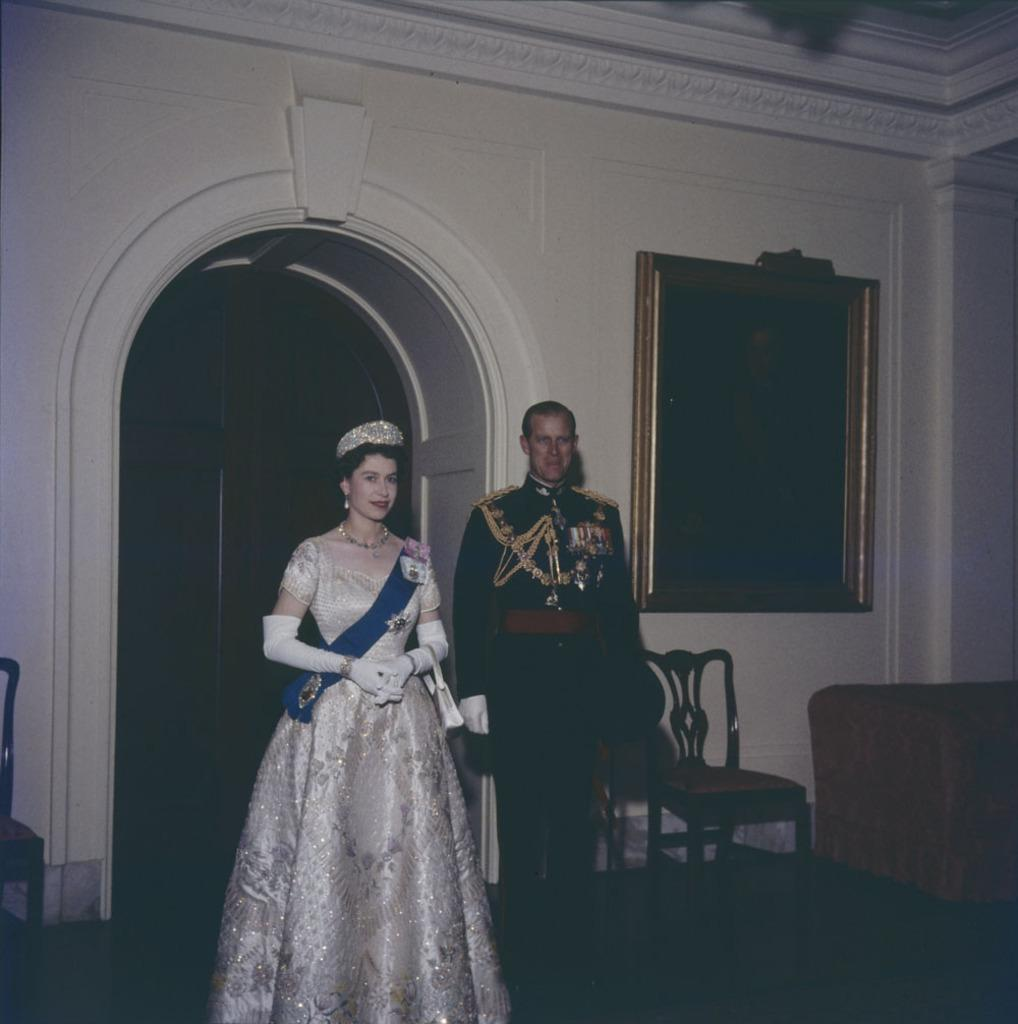How many people are in the image? There are two guys in the image. What can be seen in the background of the image? There is a wooden door in the background of the image. What furniture is located to the left of the image? There is a chair and a sofa to the left of the image. What type of wound can be seen on the doll in the image? There are no dolls present in the image, so it is not possible to determine if there is a wound on a doll. 